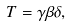<formula> <loc_0><loc_0><loc_500><loc_500>T = \gamma \beta \delta ,</formula> 